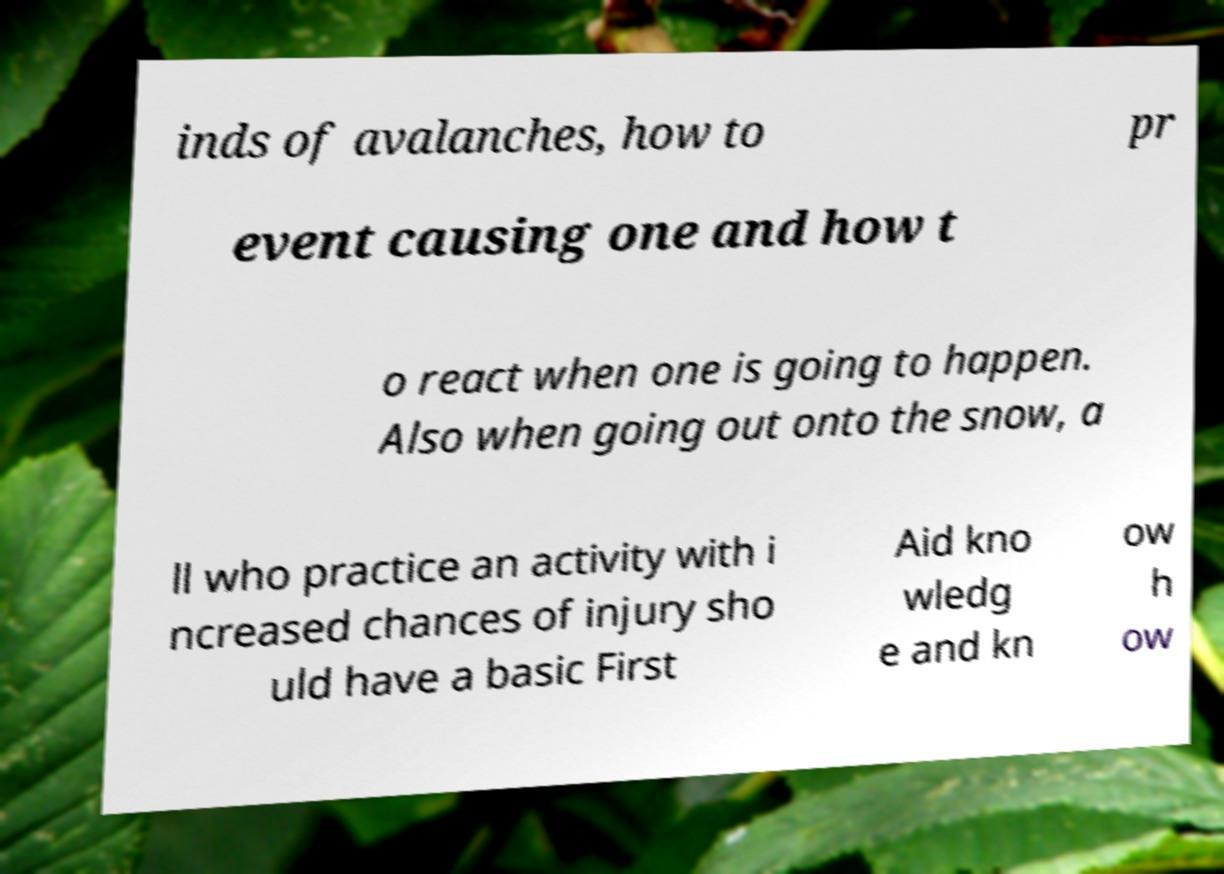Could you extract and type out the text from this image? inds of avalanches, how to pr event causing one and how t o react when one is going to happen. Also when going out onto the snow, a ll who practice an activity with i ncreased chances of injury sho uld have a basic First Aid kno wledg e and kn ow h ow 